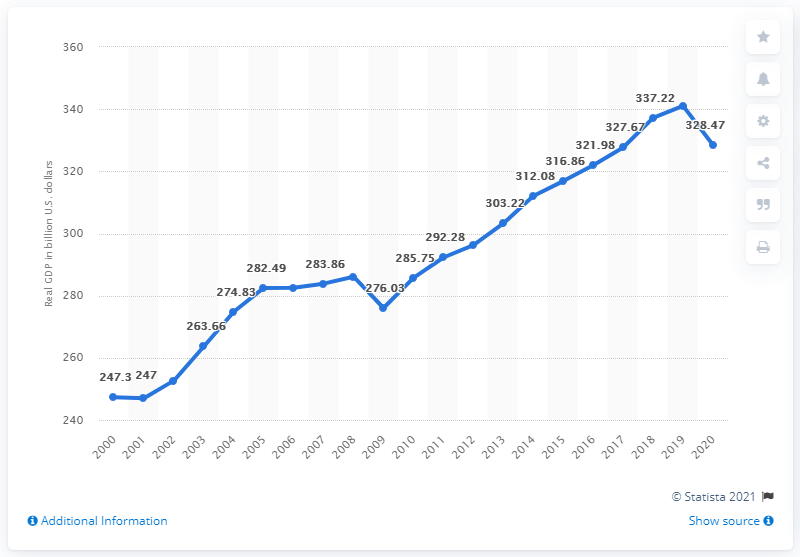Mention a couple of crucial points in this snapshot. In the year 2020, the Gross Domestic Product (GDP) of the state of Minnesota was 328.47 billion dollars. Minnesota's Gross Domestic Product (GDP) in the previous year was 341.04. 